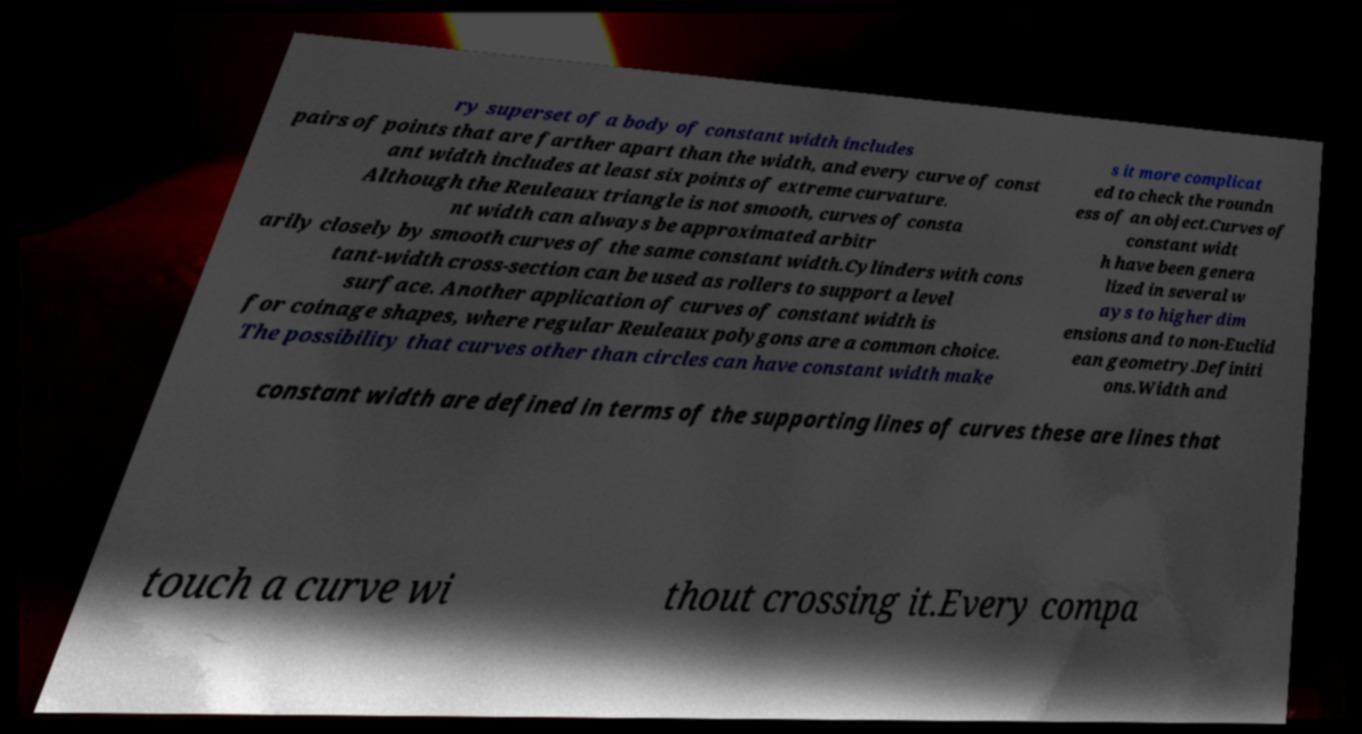What messages or text are displayed in this image? I need them in a readable, typed format. ry superset of a body of constant width includes pairs of points that are farther apart than the width, and every curve of const ant width includes at least six points of extreme curvature. Although the Reuleaux triangle is not smooth, curves of consta nt width can always be approximated arbitr arily closely by smooth curves of the same constant width.Cylinders with cons tant-width cross-section can be used as rollers to support a level surface. Another application of curves of constant width is for coinage shapes, where regular Reuleaux polygons are a common choice. The possibility that curves other than circles can have constant width make s it more complicat ed to check the roundn ess of an object.Curves of constant widt h have been genera lized in several w ays to higher dim ensions and to non-Euclid ean geometry.Definiti ons.Width and constant width are defined in terms of the supporting lines of curves these are lines that touch a curve wi thout crossing it.Every compa 